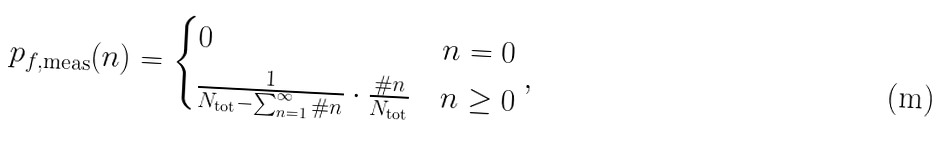<formula> <loc_0><loc_0><loc_500><loc_500>p _ { f , \text {meas} } ( n ) = \begin{cases} 0 & n = 0 \\ \frac { 1 } { N _ { \text {tot} } - \sum _ { n = 1 } ^ { \infty } \# n } \cdot \frac { \# n } { N _ { \text {tot} } } & n \geq 0 \end{cases} ,</formula> 